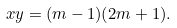<formula> <loc_0><loc_0><loc_500><loc_500>x y = ( m - 1 ) ( 2 m + 1 ) .</formula> 